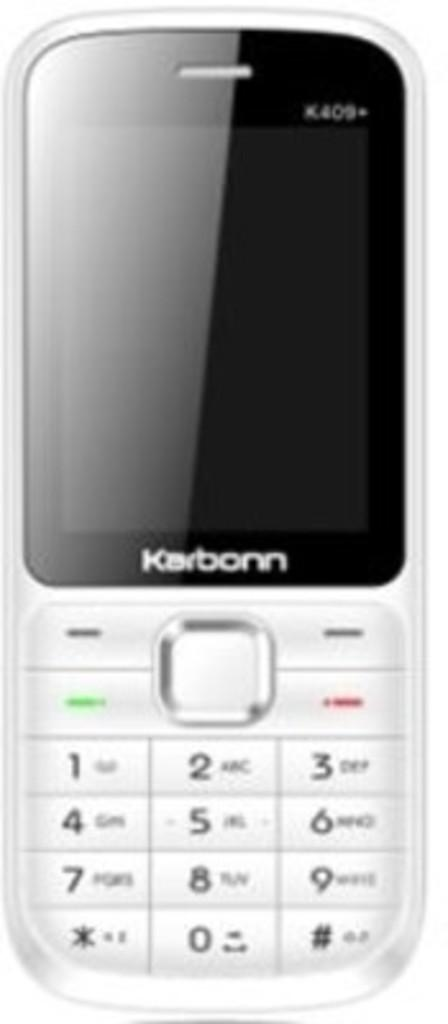<image>
Relay a brief, clear account of the picture shown. a karbonn phone that has many digits on it 